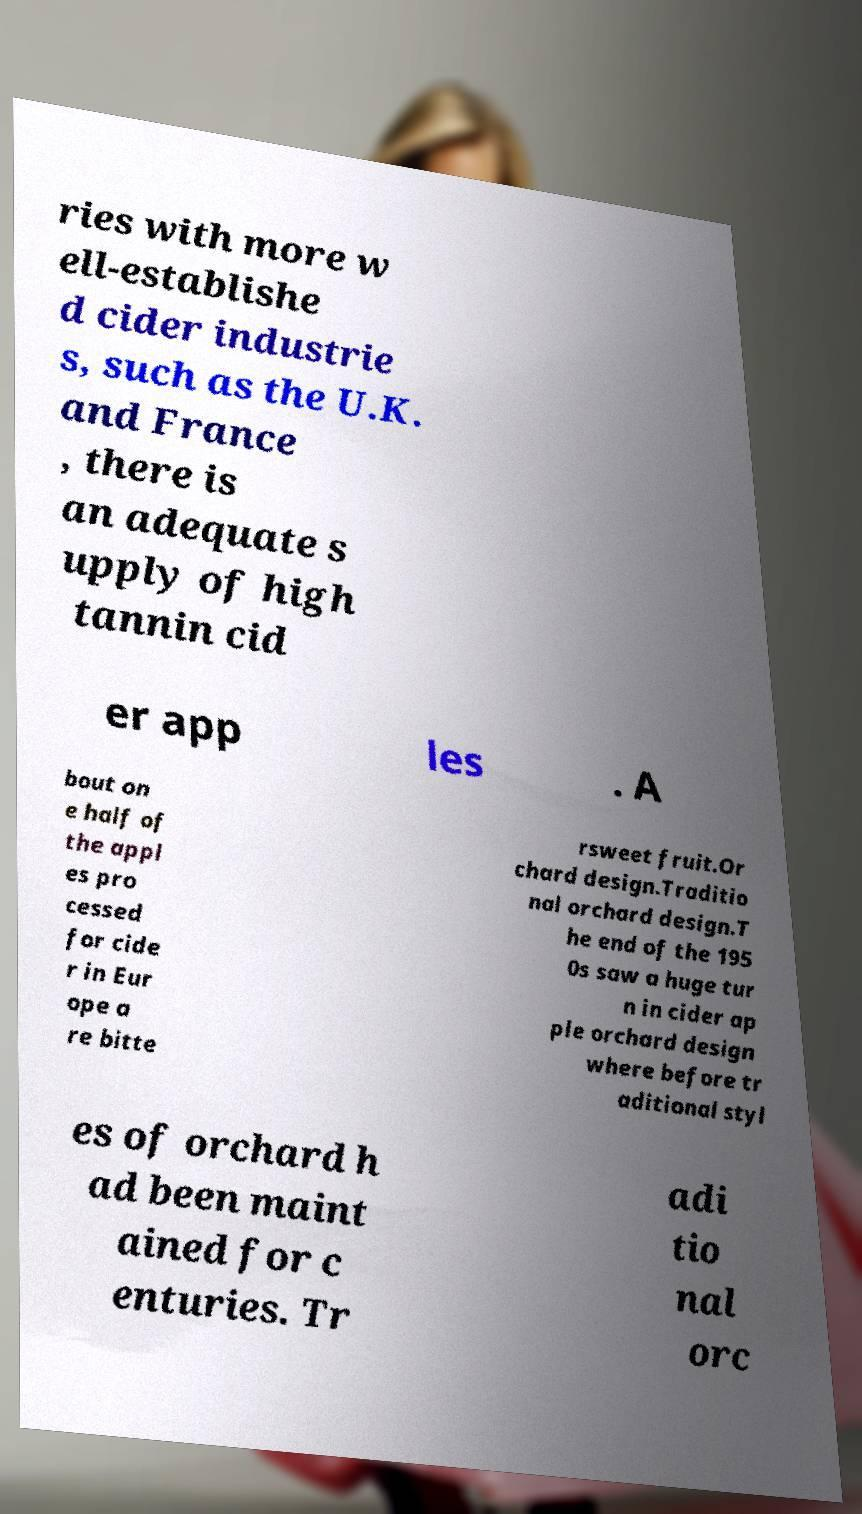For documentation purposes, I need the text within this image transcribed. Could you provide that? ries with more w ell-establishe d cider industrie s, such as the U.K. and France , there is an adequate s upply of high tannin cid er app les . A bout on e half of the appl es pro cessed for cide r in Eur ope a re bitte rsweet fruit.Or chard design.Traditio nal orchard design.T he end of the 195 0s saw a huge tur n in cider ap ple orchard design where before tr aditional styl es of orchard h ad been maint ained for c enturies. Tr adi tio nal orc 